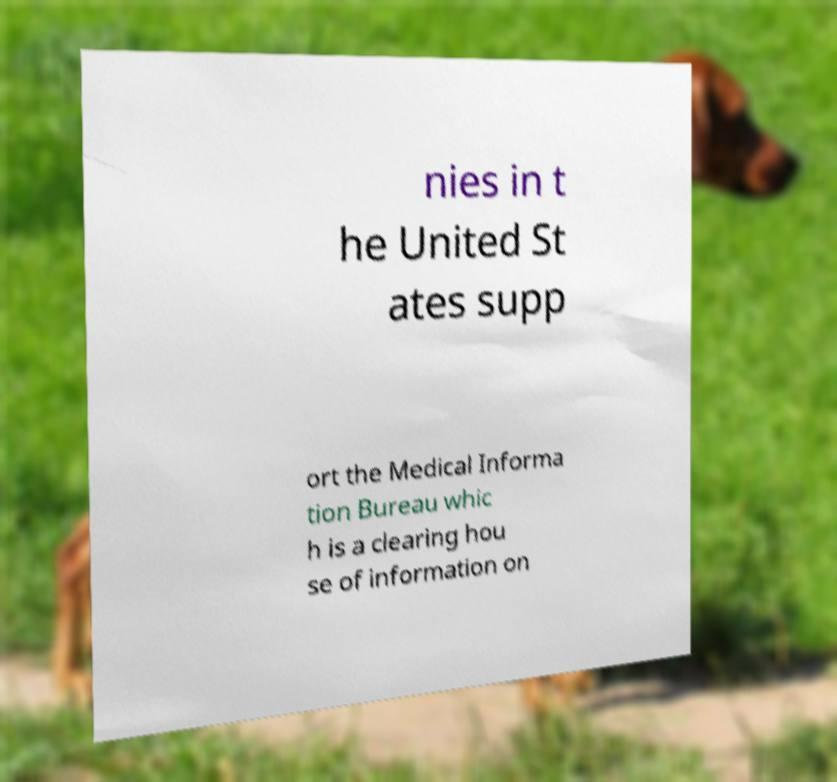Can you accurately transcribe the text from the provided image for me? nies in t he United St ates supp ort the Medical Informa tion Bureau whic h is a clearing hou se of information on 